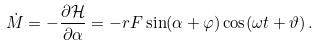<formula> <loc_0><loc_0><loc_500><loc_500>\dot { M } = - \frac { \partial \mathcal { H } } { \partial \alpha } = - r F \sin ( \alpha + \varphi ) \cos ( \omega t + \vartheta ) \, .</formula> 